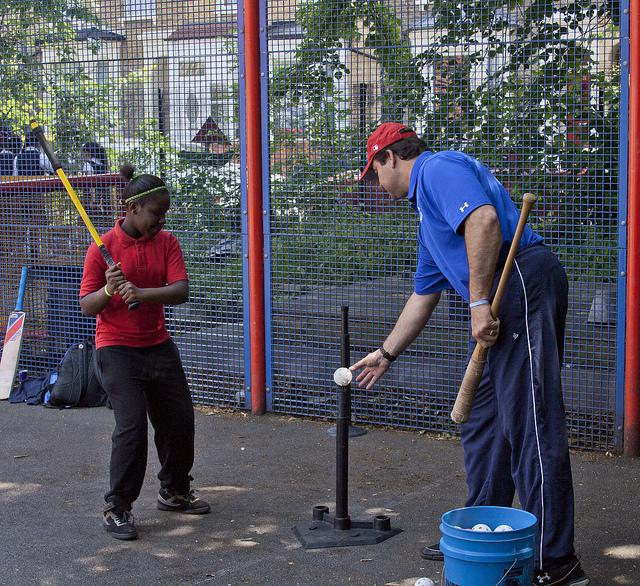What is the black pole the white ball is on called? batting tee 